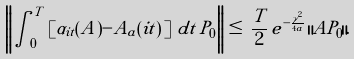<formula> <loc_0><loc_0><loc_500><loc_500>\left \| \, \int _ { 0 } ^ { T } \, \left [ \alpha _ { i t } ( A ) - A _ { a } ( i t ) \, \right ] \, d t \, P _ { 0 } \, \right \| \, \leq \, \frac { T } { 2 } \, e ^ { - \frac { \gamma ^ { 2 } } { 4 a } } \, \| A P _ { 0 } \| .</formula> 